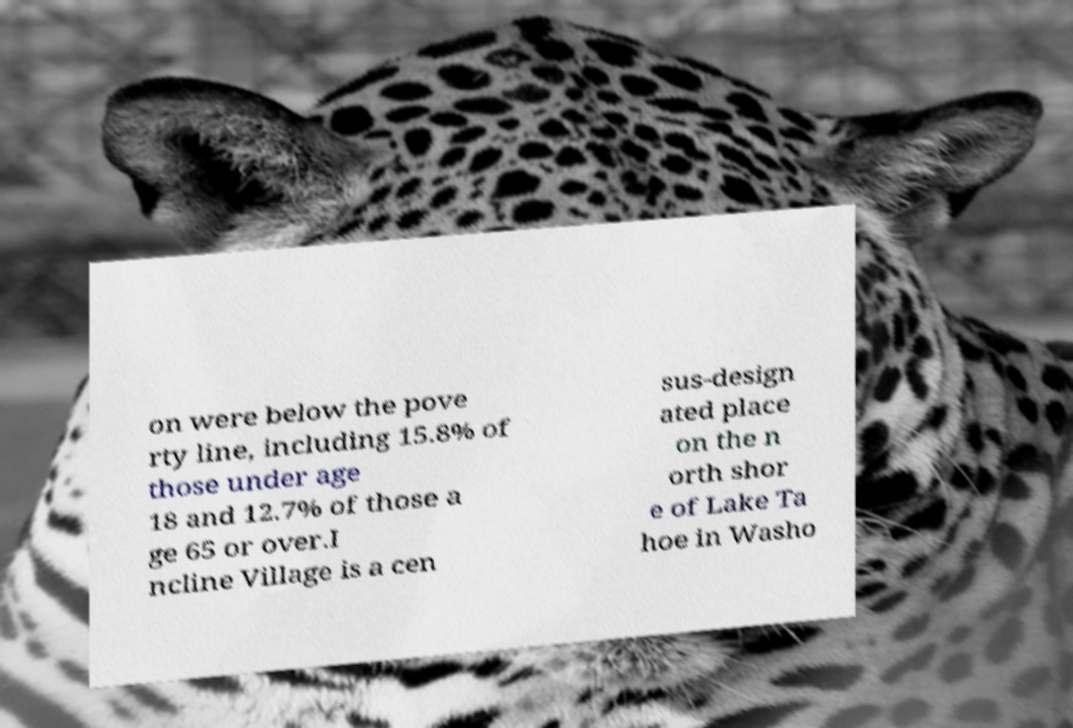Can you read and provide the text displayed in the image?This photo seems to have some interesting text. Can you extract and type it out for me? on were below the pove rty line, including 15.8% of those under age 18 and 12.7% of those a ge 65 or over.I ncline Village is a cen sus-design ated place on the n orth shor e of Lake Ta hoe in Washo 